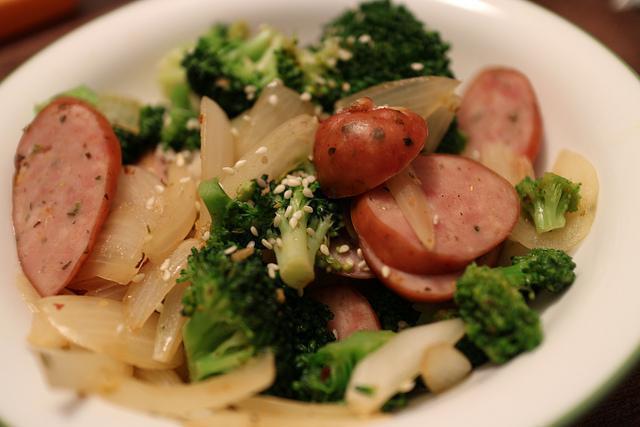How many broccolis are in the picture?
Give a very brief answer. 5. How many bowls are there?
Give a very brief answer. 1. 